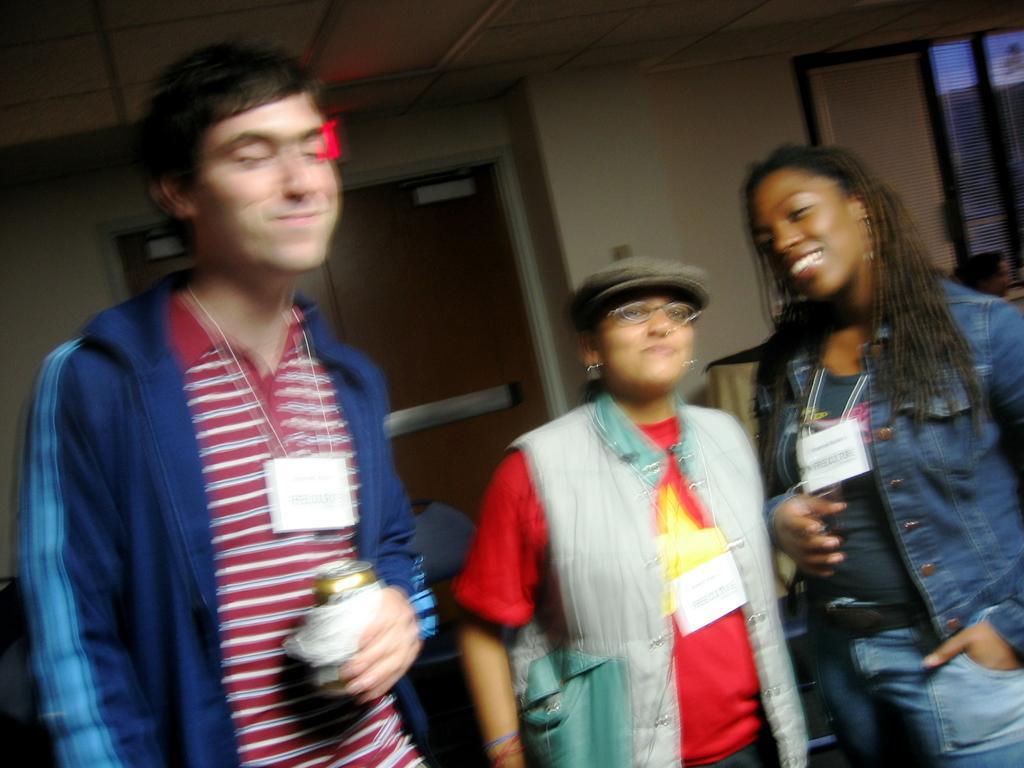In one or two sentences, can you explain what this image depicts? In this image there is a man on the left side. Beside him there are two girls. All the three people are wearing the id cards. In the background there is a door. On the right side there is a window. At the top there is ceiling. 